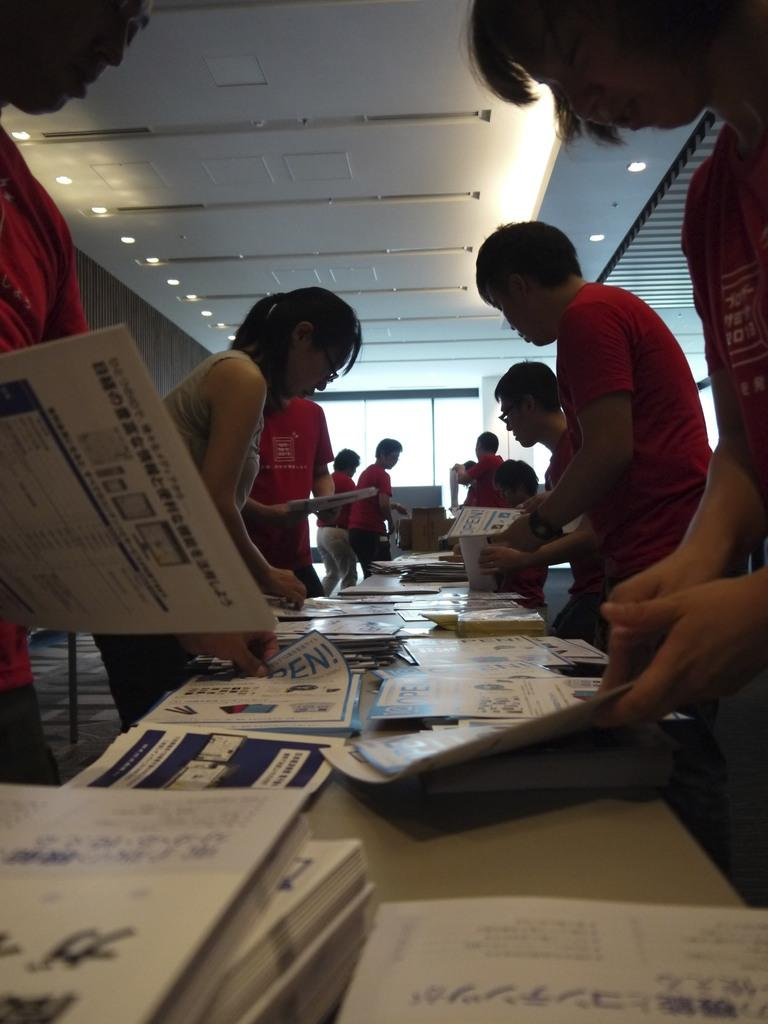What are the people in the image doing? The people in the image are standing and holding papers. What objects are present in the image that the people might use? There are tables in the image that the people might use. What else can be seen on the tables? There are additional papers on the tables. Is there any quicksand visible in the image? No, there is no quicksand present in the image. What type of instrument is being played by the people in the image? There is no instrument being played in the image; the people are holding papers. 